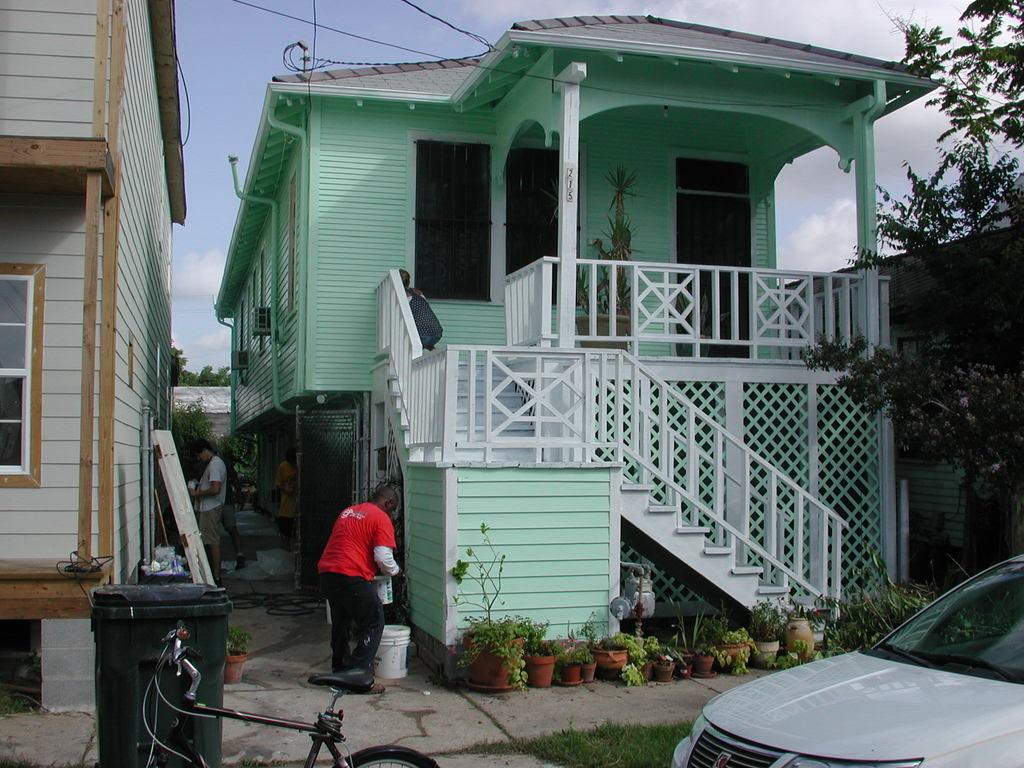What is located in the foreground of the image? In the foreground of the image, there are plants, a vehicle, a bicycle, and a trash bin. What can be seen in the background of the image? In the background of the image, there are houses, people, a tree, and the sky. How many pests can be seen on the plants in the image? There are no pests visible on the plants in the image. What type of insect is crawling on the ladybug in the image? There is no ladybug present in the image, so it is not possible to determine what type of insect might be crawling on it. 